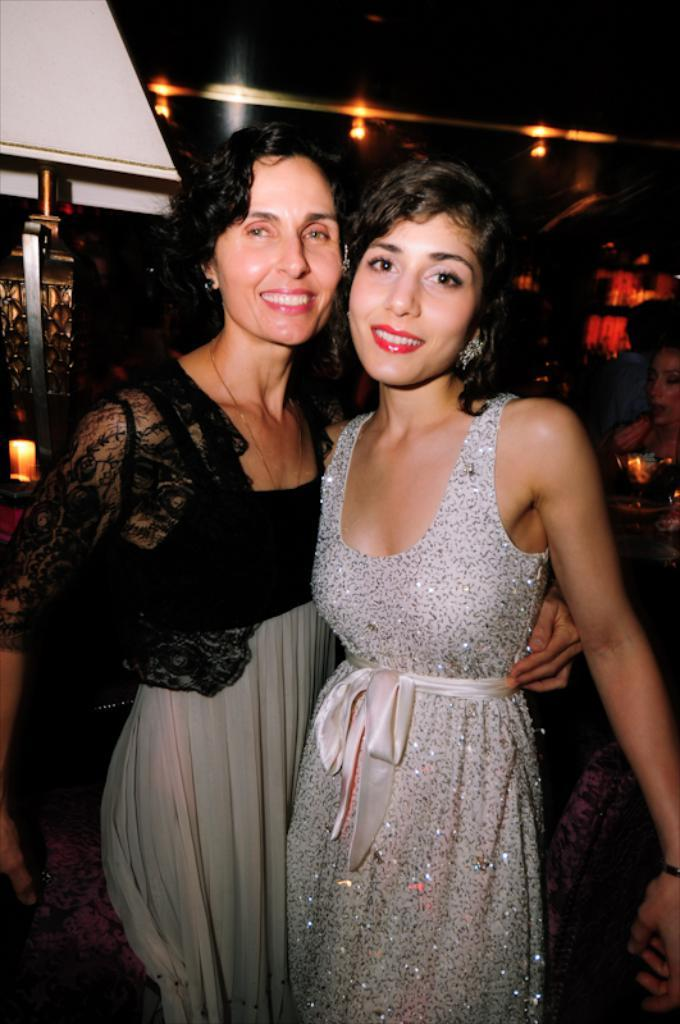How many women are in the image? There are two women standing in the image. Can you describe the background of the image? In the background of the image, there are few persons, candle lights, metal objects, and lights. What type of objects are visible in the background of the image? Metal objects and candle lights are visible in the background of the image. What type of robin can be seen perched on the clock in the image? There is no robin or clock present in the image. What position are the women in the image? The provided facts do not specify the position or stance of the women in the image. 